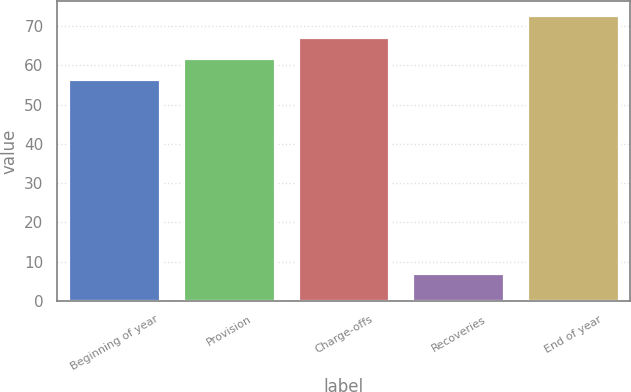<chart> <loc_0><loc_0><loc_500><loc_500><bar_chart><fcel>Beginning of year<fcel>Provision<fcel>Charge-offs<fcel>Recoveries<fcel>End of year<nl><fcel>56.5<fcel>61.93<fcel>67.36<fcel>7.1<fcel>72.79<nl></chart> 